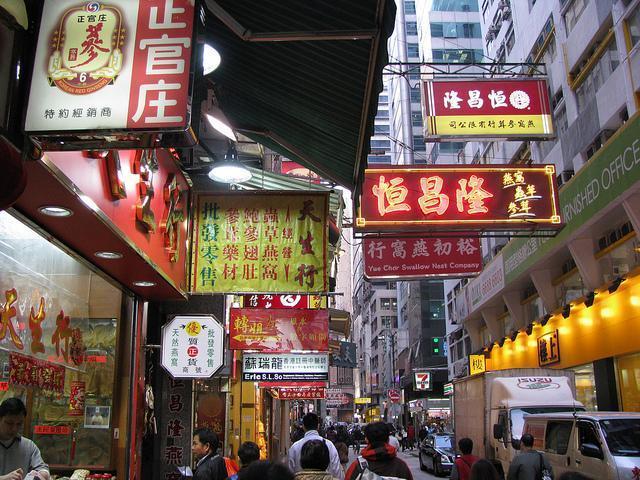How many trucks are there?
Give a very brief answer. 1. How many horses are shown?
Give a very brief answer. 0. 